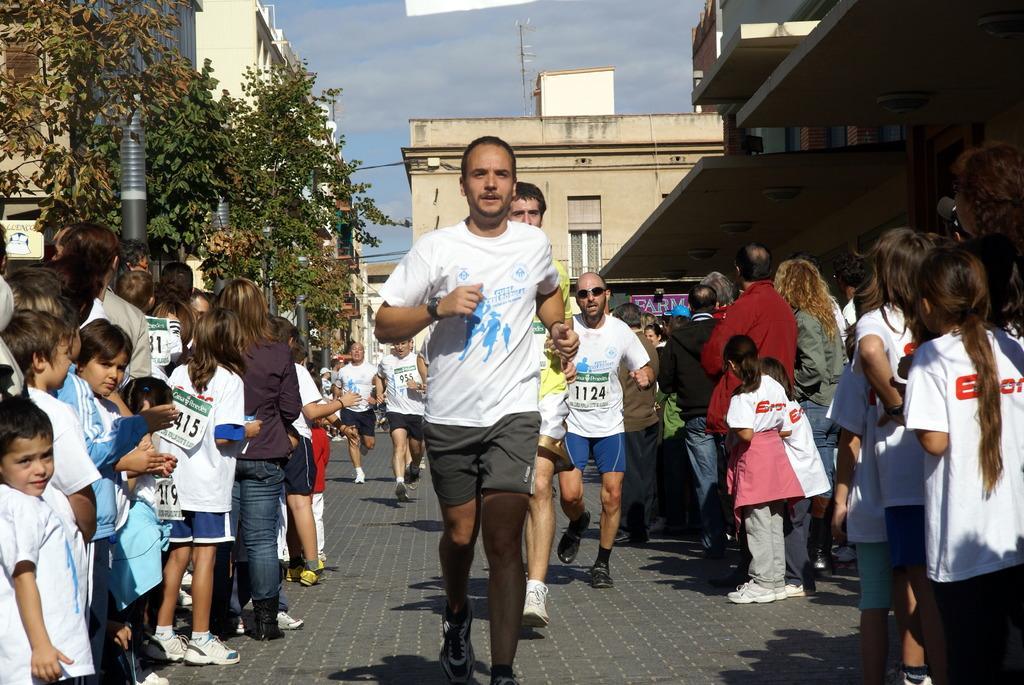Can you describe this image briefly? In this image I can see the group of people with different color dresses. I can see few people attach stickers to the dresses. To the side of these people I can see the poles, trees and many buildings. In the background I can see the sky. 